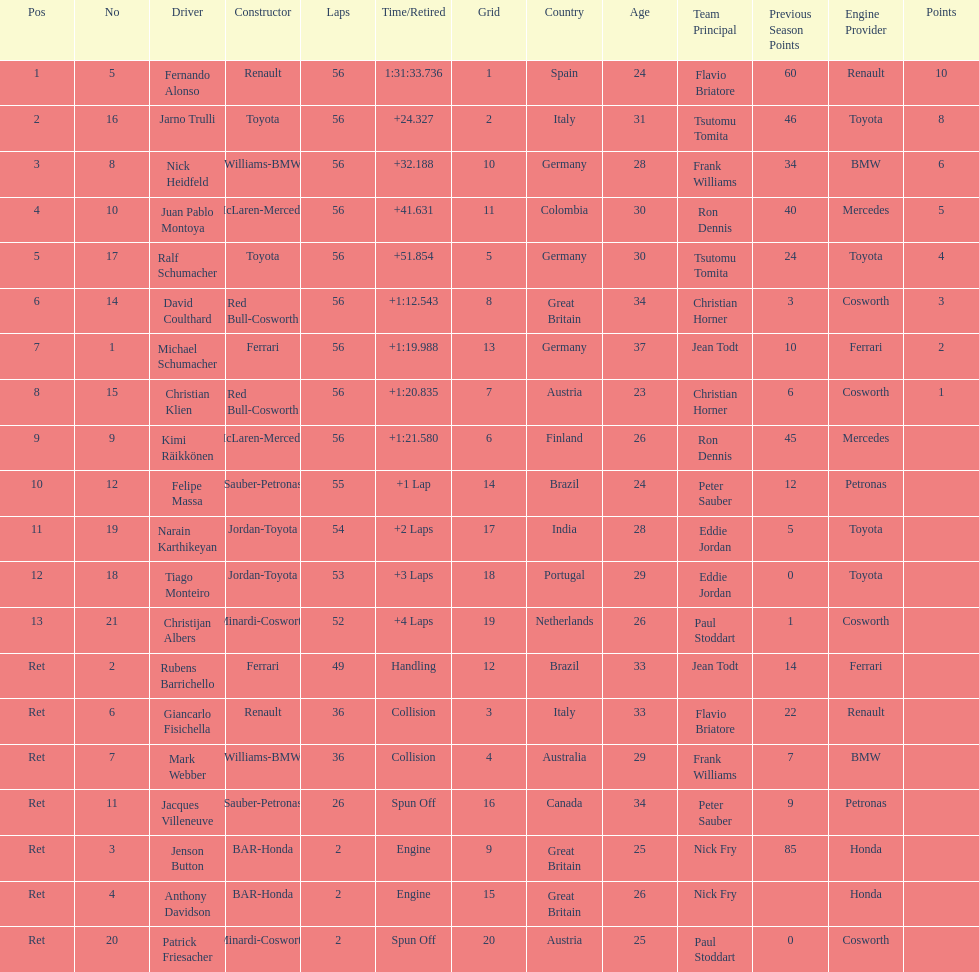Could you help me parse every detail presented in this table? {'header': ['Pos', 'No', 'Driver', 'Constructor', 'Laps', 'Time/Retired', 'Grid', 'Country', 'Age', 'Team Principal', 'Previous Season Points', 'Engine Provider', 'Points'], 'rows': [['1', '5', 'Fernando Alonso', 'Renault', '56', '1:31:33.736', '1', 'Spain', '24', 'Flavio Briatore', '60', 'Renault', '10'], ['2', '16', 'Jarno Trulli', 'Toyota', '56', '+24.327', '2', 'Italy', '31', 'Tsutomu Tomita', '46', 'Toyota', '8'], ['3', '8', 'Nick Heidfeld', 'Williams-BMW', '56', '+32.188', '10', 'Germany', '28', 'Frank Williams', '34', 'BMW', '6'], ['4', '10', 'Juan Pablo Montoya', 'McLaren-Mercedes', '56', '+41.631', '11', 'Colombia', '30', 'Ron Dennis', '40', 'Mercedes', '5'], ['5', '17', 'Ralf Schumacher', 'Toyota', '56', '+51.854', '5', 'Germany', '30', 'Tsutomu Tomita', '24', 'Toyota', '4'], ['6', '14', 'David Coulthard', 'Red Bull-Cosworth', '56', '+1:12.543', '8', 'Great Britain', '34', 'Christian Horner', '3', 'Cosworth', '3'], ['7', '1', 'Michael Schumacher', 'Ferrari', '56', '+1:19.988', '13', 'Germany', '37', 'Jean Todt', '10', 'Ferrari', '2'], ['8', '15', 'Christian Klien', 'Red Bull-Cosworth', '56', '+1:20.835', '7', 'Austria', '23', 'Christian Horner', '6', 'Cosworth', '1'], ['9', '9', 'Kimi Räikkönen', 'McLaren-Mercedes', '56', '+1:21.580', '6', 'Finland', '26', 'Ron Dennis', '45', 'Mercedes', ''], ['10', '12', 'Felipe Massa', 'Sauber-Petronas', '55', '+1 Lap', '14', 'Brazil', '24', 'Peter Sauber', '12', 'Petronas', ''], ['11', '19', 'Narain Karthikeyan', 'Jordan-Toyota', '54', '+2 Laps', '17', 'India', '28', 'Eddie Jordan', '5', 'Toyota', ''], ['12', '18', 'Tiago Monteiro', 'Jordan-Toyota', '53', '+3 Laps', '18', 'Portugal', '29', 'Eddie Jordan', '0', 'Toyota', ''], ['13', '21', 'Christijan Albers', 'Minardi-Cosworth', '52', '+4 Laps', '19', 'Netherlands', '26', 'Paul Stoddart', '1', 'Cosworth', ''], ['Ret', '2', 'Rubens Barrichello', 'Ferrari', '49', 'Handling', '12', 'Brazil', '33', 'Jean Todt', '14', 'Ferrari', ''], ['Ret', '6', 'Giancarlo Fisichella', 'Renault', '36', 'Collision', '3', 'Italy', '33', 'Flavio Briatore', '22', 'Renault', ''], ['Ret', '7', 'Mark Webber', 'Williams-BMW', '36', 'Collision', '4', 'Australia', '29', 'Frank Williams', '7', 'BMW', ''], ['Ret', '11', 'Jacques Villeneuve', 'Sauber-Petronas', '26', 'Spun Off', '16', 'Canada', '34', 'Peter Sauber', '9', 'Petronas', ''], ['Ret', '3', 'Jenson Button', 'BAR-Honda', '2', 'Engine', '9', 'Great Britain', '25', 'Nick Fry', '85', 'Honda', ''], ['Ret', '4', 'Anthony Davidson', 'BAR-Honda', '2', 'Engine', '15', 'Great Britain', '26', 'Nick Fry', '', 'Honda', ''], ['Ret', '20', 'Patrick Friesacher', 'Minardi-Cosworth', '2', 'Spun Off', '20', 'Austria', '25', 'Paul Stoddart', '0', 'Cosworth', '']]} For the competitor who secured the 1st position, what was their completed lap count? 56. 